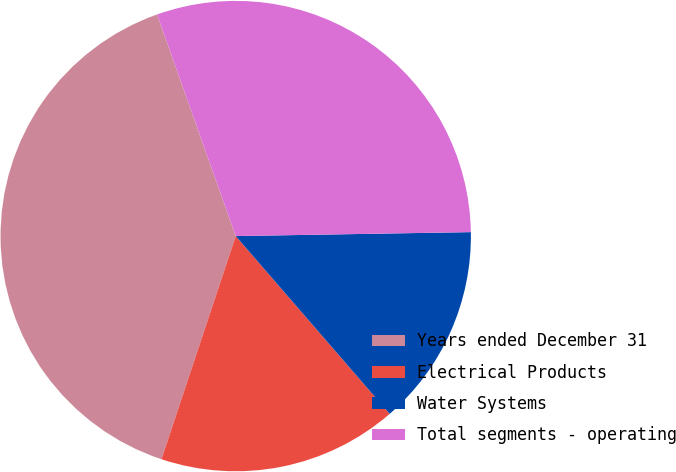<chart> <loc_0><loc_0><loc_500><loc_500><pie_chart><fcel>Years ended December 31<fcel>Electrical Products<fcel>Water Systems<fcel>Total segments - operating<nl><fcel>39.46%<fcel>16.47%<fcel>13.91%<fcel>30.16%<nl></chart> 